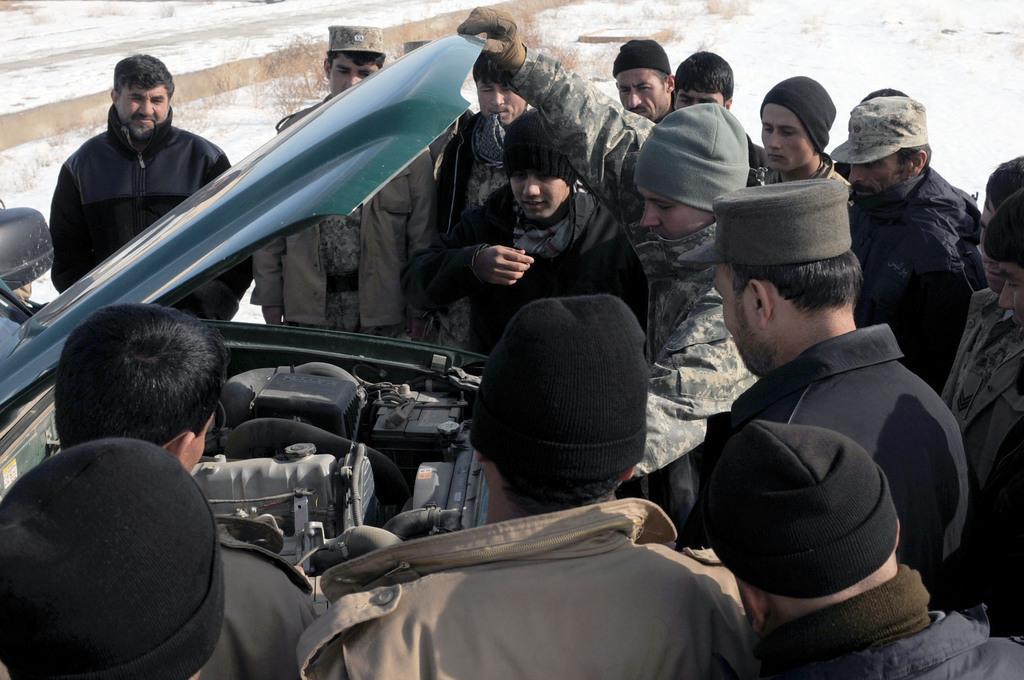Describe this image in one or two sentences. In this picture I can see there are some people standing and there is a car breakdown here and they are checking it. In the backdrop I can see there are plants and snow on the floor. 